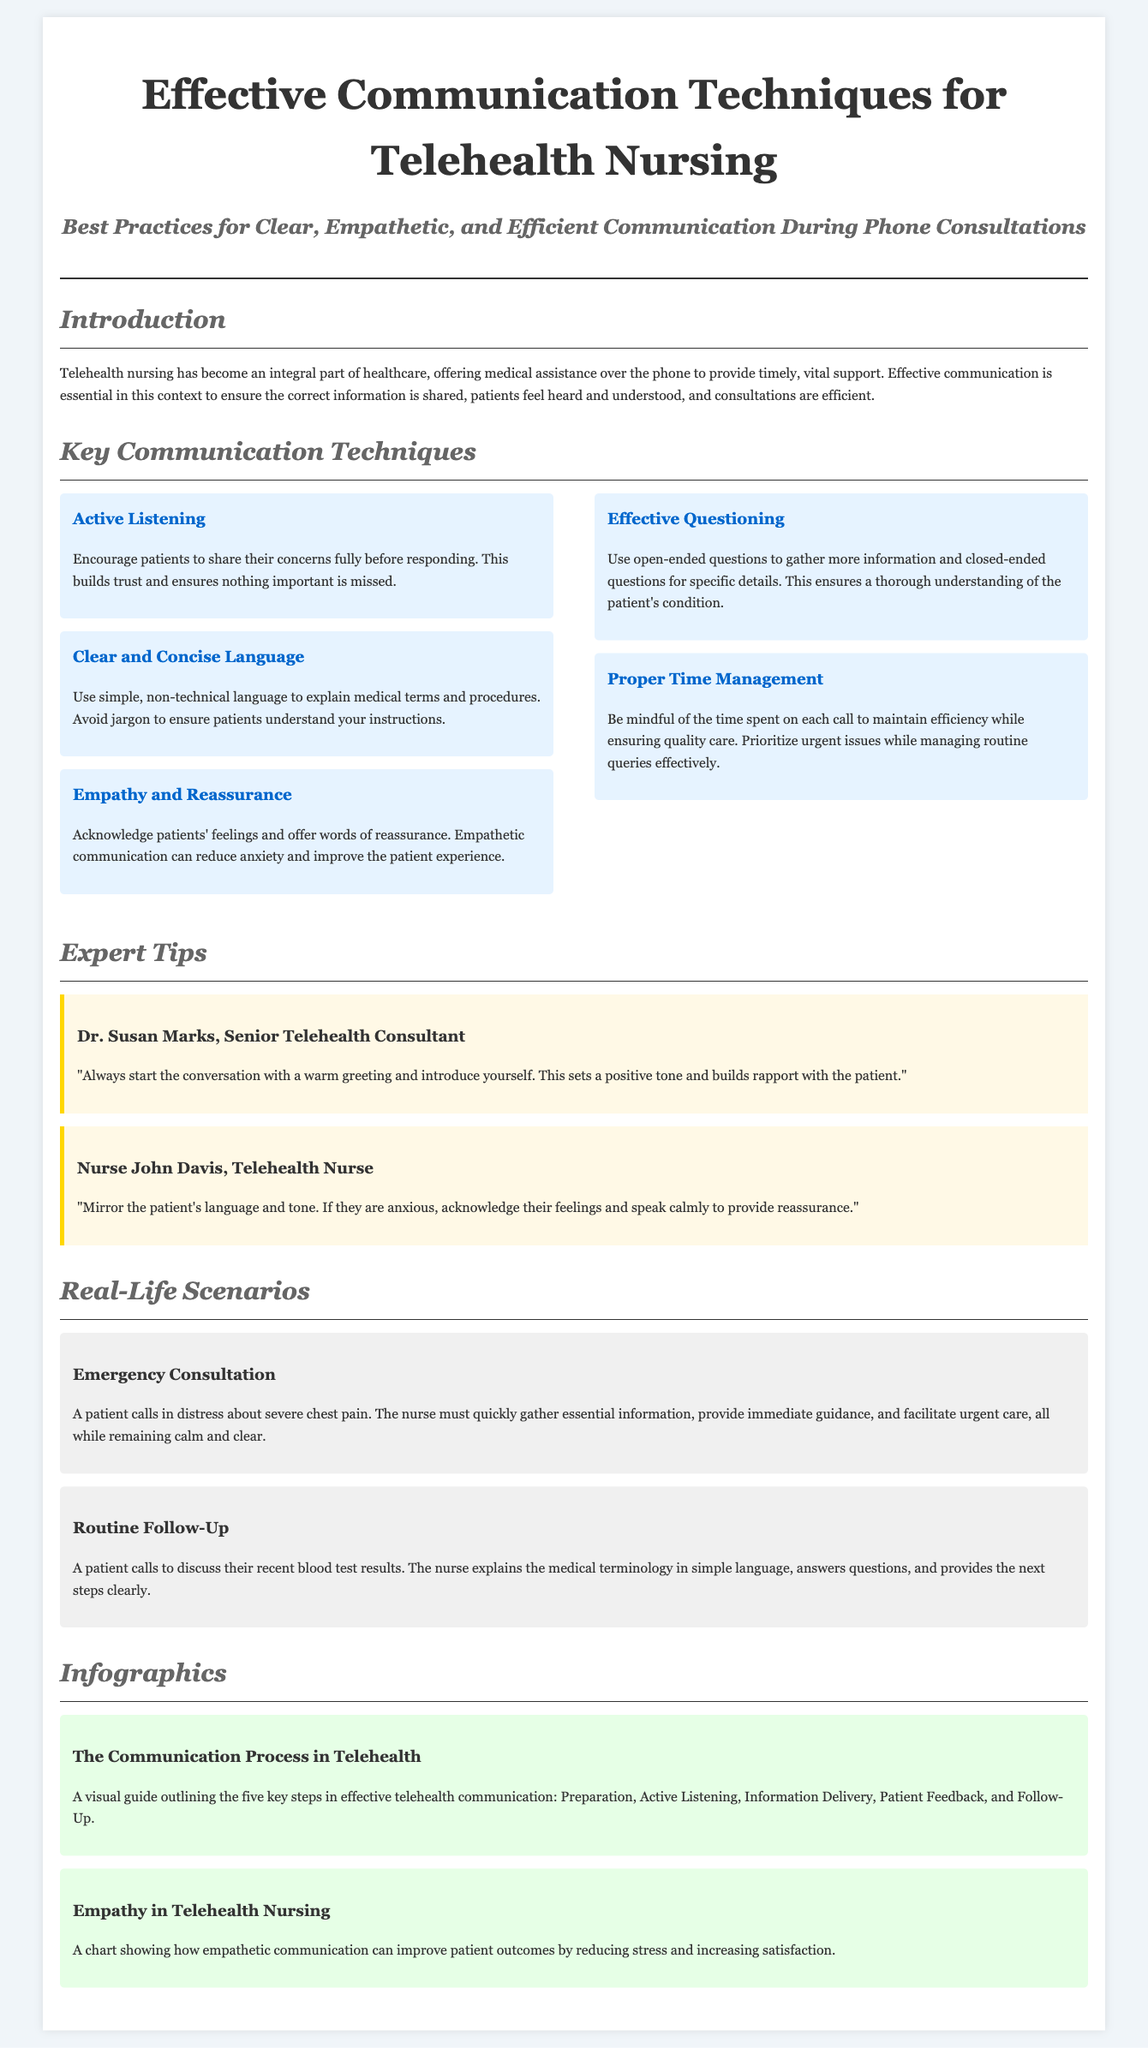what is the title of the feature piece? The title is prominently displayed at the top of the document and provides the main focus of the article.
Answer: Effective Communication Techniques for Telehealth Nursing who is the Senior Telehealth Consultant quoted in the document? This information is found in the section where expert tips are provided, which cites professionals in the field.
Answer: Dr. Susan Marks how many key communication techniques are listed in the article? The article outlines various techniques in one of its sections, which allows us to count them.
Answer: Five what is one technique mentioned for improving patient experience? This technique can be found in the list of key communication techniques focusing on how to interact with patients.
Answer: Empathy and Reassurance what type of scenarios are provided in the document? The scenarios illustrate practical examples related to telehealth nursing consultations, which help understand application in real situations.
Answer: Real-Life Scenarios which section contains expert tips? The section structure of the document identifies where specific recommendations from industry professionals can be found.
Answer: Expert Tips 